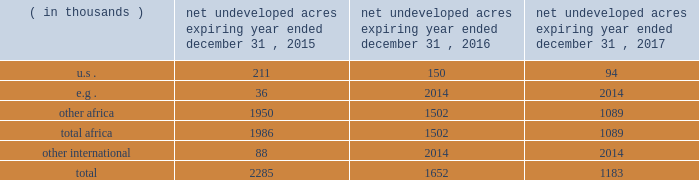In the ordinary course of business , based on our evaluations of certain geologic trends and prospective economics , we have allowed certain lease acreage to expire and may allow additional acreage to expire in the future .
If production is not established or we take no other action to extend the terms of the leases , licenses , or concessions , undeveloped acreage listed in the table below will expire over the next three years .
We plan to continue the terms of many of these licenses and concession areas or retain leases through operational or administrative actions .
Net undeveloped acres expiring year ended december 31 .
Oil sands mining segment we hold a 20 percent non-operated interest in the aosp , an oil sands mining and upgrading joint venture located in alberta , canada .
The joint venture produces bitumen from oil sands deposits in the athabasca region utilizing mining techniques and upgrades the bitumen to synthetic crude oils and vacuum gas oil .
The aosp 2019s mining and extraction assets are located near fort mcmurray , alberta , and include the muskeg river and the jackpine mines .
Gross design capacity of the combined mines is 255000 ( 51000 net to our interest ) barrels of bitumen per day .
The aosp operations use established processes to mine oil sands deposits from an open-pit mine , extract the bitumen and upgrade it into synthetic crude oils .
Ore is mined using traditional truck and shovel mining techniques .
The mined ore passes through primary crushers to reduce the ore chunks in size and is then sent to rotary breakers where the ore chunks are further reduced to smaller particles .
The particles are combined with hot water to create slurry .
The slurry moves through the extraction process where it separates into sand , clay and bitumen-rich froth .
A solvent is added to the bitumen froth to separate out the remaining solids , water and heavy asphaltenes .
The solvent washes the sand and produces clean bitumen that is required for the upgrader to run efficiently .
The process yields a mixture of solvent and bitumen which is then transported from the mine to the scotford upgrader via the approximately 300-mile corridor pipeline .
The aosp's scotford upgrader is located at fort saskatchewan , northeast of edmonton , alberta .
The bitumen is upgraded at scotford using both hydrotreating and hydroconversion processes to remove sulfur and break the heavy bitumen molecules into lighter products .
Blendstocks acquired from outside sources are utilized in the production of our saleable products .
The upgrader produces synthetic crude oils and vacuum gas oil .
The vacuum gas oil is sold to an affiliate of the operator under a long-term contract at market-related prices , and the other products are sold in the marketplace .
As of december 31 , 2014 , we own or have rights to participate in developed and undeveloped leases totaling approximately 163000 gross ( 33000 net ) acres .
The underlying developed leases are held for the duration of the project , with royalties payable to the province of alberta .
Synthetic crude oil sales volumes for 2014 averaged 50 mbbld and net-of-royalty production was 41 mbbld .
In december 2013 , a jackpine mine expansion project received conditional approval from the canadian government .
The project includes additional mining areas , associated processing facilities and infrastructure .
The government conditions relate to wildlife , the environment and aboriginal health issues .
We will evaluate the potential expansion project and government conditions after infrastructure reliability initiatives are completed .
The governments of alberta and canada have agreed to partially fund quest ccs for $ 865 million canadian .
In the third quarter of 2012 , the energy and resources conservation board ( "ercb" ) , alberta's primary energy regulator at that time , conditionally approved the project and the aosp partners approved proceeding to construct and operate quest ccs .
Government funding commenced in 2012 and continued as milestones were achieved during the development , construction and operating phases .
Failure of the aosp to meet certain timing , performance and operating objectives may result in repaying some of the government funding .
Construction and commissioning of quest ccs is expected to be completed by late 2015. .
What are total african net undeveloped acres in thousands for 12/31/15? 
Computations: (1950 + 1986)
Answer: 3936.0. 